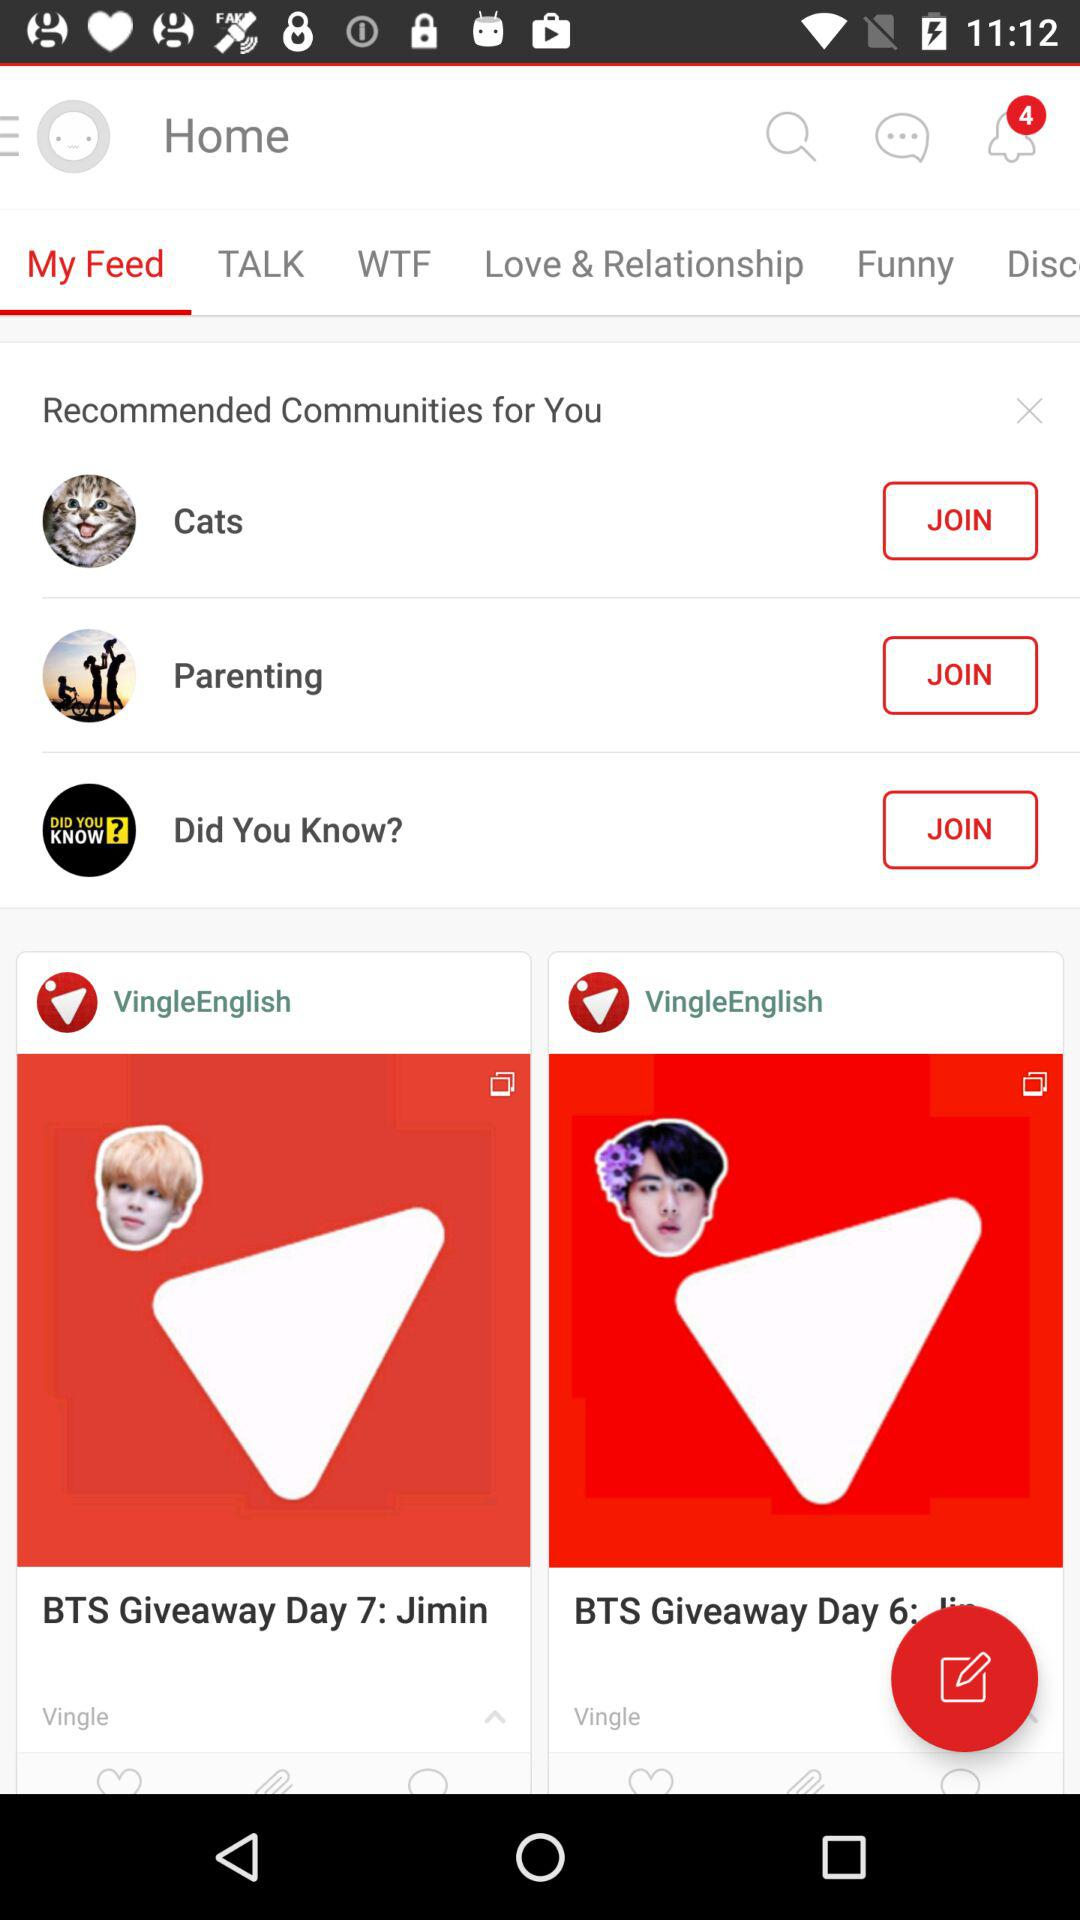Which tab is currently selected? The currently selected tab is "My Feed". 